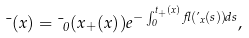Convert formula to latex. <formula><loc_0><loc_0><loc_500><loc_500>\mu ( x ) = \mu _ { 0 } ( x _ { + } ( x ) ) e ^ { - \int _ { 0 } ^ { t _ { + } ( x ) } \gamma ( \varphi _ { x } ( s ) ) d s } ,</formula> 